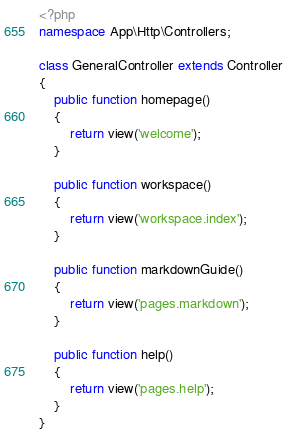Convert code to text. <code><loc_0><loc_0><loc_500><loc_500><_PHP_><?php
namespace App\Http\Controllers;

class GeneralController extends Controller
{
    public function homepage()
    {
        return view('welcome');
    }

    public function workspace()
    {
        return view('workspace.index');
    }

    public function markdownGuide()
    {
        return view('pages.markdown');
    }

    public function help()
    {
        return view('pages.help');
    }
}
</code> 